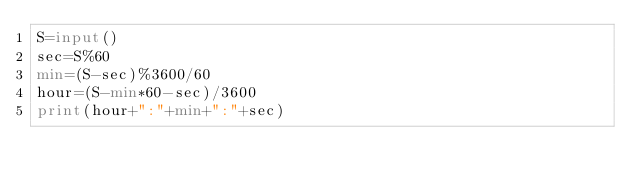<code> <loc_0><loc_0><loc_500><loc_500><_Python_>S=input()
sec=S%60
min=(S-sec)%3600/60
hour=(S-min*60-sec)/3600
print(hour+":"+min+":"+sec)</code> 